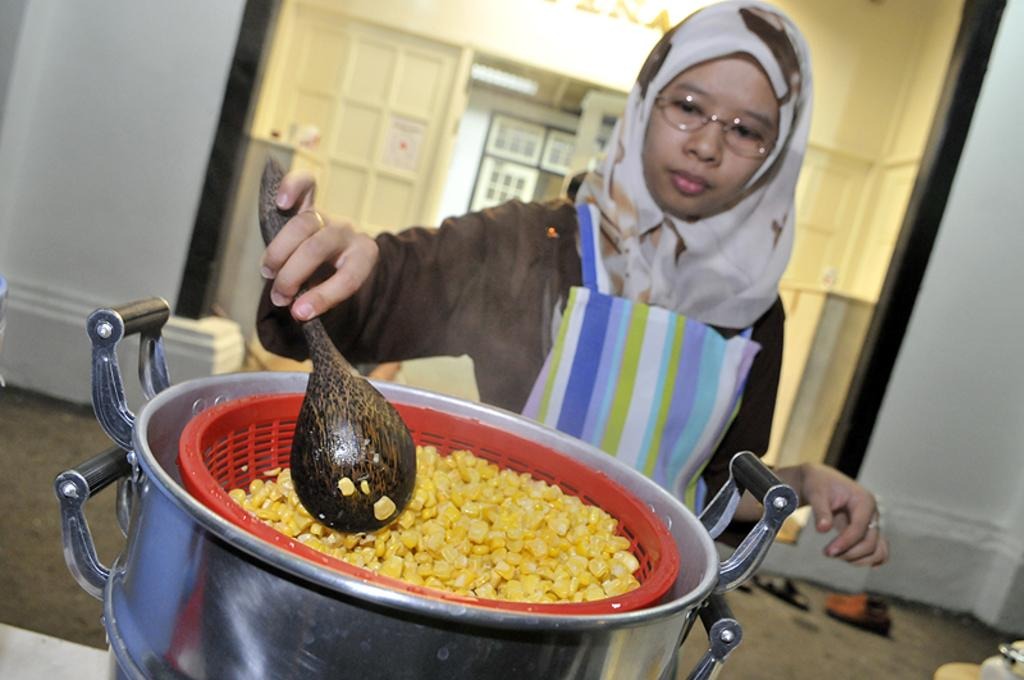What is happening in the image? There is a person in the image who is cooking a food item. What material is the cooking surface made of? The cooking is being done in a silver metal. What type of horse is being sorted in the image? There is no horse or sorting activity present in the image; it features a person cooking in a silver metal. What game is being played in the image? There is no game being played in the image; it features a person cooking in a silver metal. 